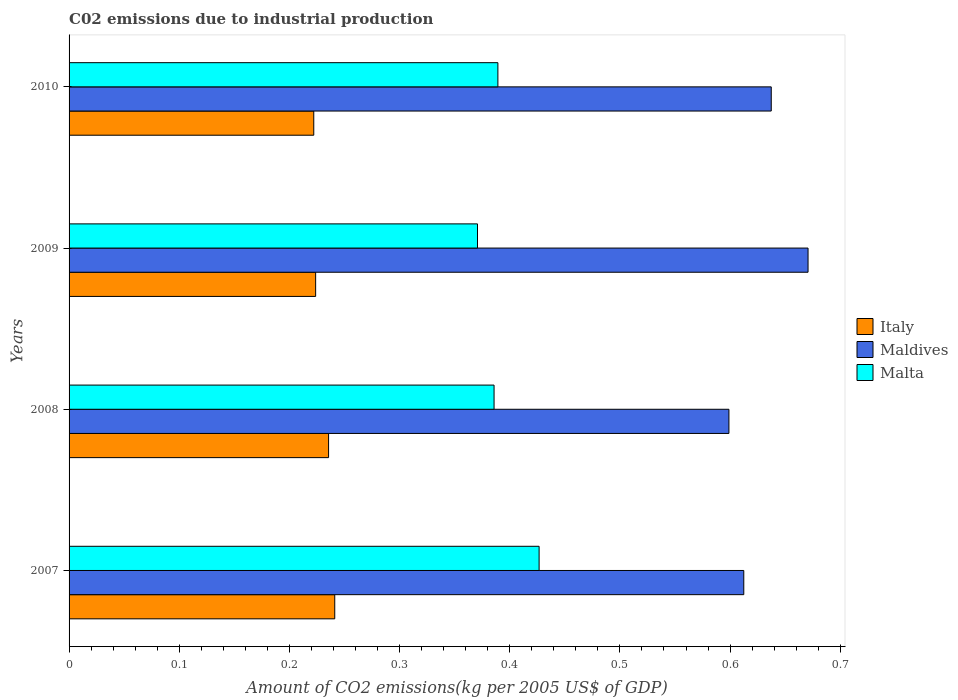How many different coloured bars are there?
Provide a short and direct response. 3. How many bars are there on the 3rd tick from the top?
Ensure brevity in your answer.  3. What is the amount of CO2 emitted due to industrial production in Italy in 2010?
Provide a short and direct response. 0.22. Across all years, what is the maximum amount of CO2 emitted due to industrial production in Maldives?
Offer a terse response. 0.67. Across all years, what is the minimum amount of CO2 emitted due to industrial production in Italy?
Offer a very short reply. 0.22. In which year was the amount of CO2 emitted due to industrial production in Maldives minimum?
Provide a short and direct response. 2008. What is the total amount of CO2 emitted due to industrial production in Malta in the graph?
Provide a succinct answer. 1.57. What is the difference between the amount of CO2 emitted due to industrial production in Maldives in 2008 and that in 2009?
Provide a short and direct response. -0.07. What is the difference between the amount of CO2 emitted due to industrial production in Maldives in 2010 and the amount of CO2 emitted due to industrial production in Italy in 2007?
Your answer should be compact. 0.4. What is the average amount of CO2 emitted due to industrial production in Italy per year?
Offer a terse response. 0.23. In the year 2009, what is the difference between the amount of CO2 emitted due to industrial production in Malta and amount of CO2 emitted due to industrial production in Maldives?
Keep it short and to the point. -0.3. What is the ratio of the amount of CO2 emitted due to industrial production in Malta in 2007 to that in 2009?
Offer a terse response. 1.15. Is the difference between the amount of CO2 emitted due to industrial production in Malta in 2007 and 2010 greater than the difference between the amount of CO2 emitted due to industrial production in Maldives in 2007 and 2010?
Ensure brevity in your answer.  Yes. What is the difference between the highest and the second highest amount of CO2 emitted due to industrial production in Maldives?
Your answer should be very brief. 0.03. What is the difference between the highest and the lowest amount of CO2 emitted due to industrial production in Italy?
Your answer should be very brief. 0.02. In how many years, is the amount of CO2 emitted due to industrial production in Malta greater than the average amount of CO2 emitted due to industrial production in Malta taken over all years?
Your answer should be compact. 1. What does the 3rd bar from the bottom in 2008 represents?
Ensure brevity in your answer.  Malta. How many bars are there?
Provide a succinct answer. 12. Are all the bars in the graph horizontal?
Your answer should be compact. Yes. How many years are there in the graph?
Give a very brief answer. 4. Are the values on the major ticks of X-axis written in scientific E-notation?
Your answer should be very brief. No. Where does the legend appear in the graph?
Ensure brevity in your answer.  Center right. What is the title of the graph?
Keep it short and to the point. C02 emissions due to industrial production. Does "Malta" appear as one of the legend labels in the graph?
Your answer should be very brief. Yes. What is the label or title of the X-axis?
Your answer should be compact. Amount of CO2 emissions(kg per 2005 US$ of GDP). What is the Amount of CO2 emissions(kg per 2005 US$ of GDP) in Italy in 2007?
Keep it short and to the point. 0.24. What is the Amount of CO2 emissions(kg per 2005 US$ of GDP) of Maldives in 2007?
Your answer should be very brief. 0.61. What is the Amount of CO2 emissions(kg per 2005 US$ of GDP) of Malta in 2007?
Make the answer very short. 0.43. What is the Amount of CO2 emissions(kg per 2005 US$ of GDP) in Italy in 2008?
Keep it short and to the point. 0.24. What is the Amount of CO2 emissions(kg per 2005 US$ of GDP) of Maldives in 2008?
Offer a very short reply. 0.6. What is the Amount of CO2 emissions(kg per 2005 US$ of GDP) in Malta in 2008?
Provide a succinct answer. 0.39. What is the Amount of CO2 emissions(kg per 2005 US$ of GDP) of Italy in 2009?
Your response must be concise. 0.22. What is the Amount of CO2 emissions(kg per 2005 US$ of GDP) in Maldives in 2009?
Ensure brevity in your answer.  0.67. What is the Amount of CO2 emissions(kg per 2005 US$ of GDP) of Malta in 2009?
Ensure brevity in your answer.  0.37. What is the Amount of CO2 emissions(kg per 2005 US$ of GDP) in Italy in 2010?
Offer a terse response. 0.22. What is the Amount of CO2 emissions(kg per 2005 US$ of GDP) of Maldives in 2010?
Your response must be concise. 0.64. What is the Amount of CO2 emissions(kg per 2005 US$ of GDP) of Malta in 2010?
Keep it short and to the point. 0.39. Across all years, what is the maximum Amount of CO2 emissions(kg per 2005 US$ of GDP) in Italy?
Your response must be concise. 0.24. Across all years, what is the maximum Amount of CO2 emissions(kg per 2005 US$ of GDP) of Maldives?
Keep it short and to the point. 0.67. Across all years, what is the maximum Amount of CO2 emissions(kg per 2005 US$ of GDP) in Malta?
Offer a terse response. 0.43. Across all years, what is the minimum Amount of CO2 emissions(kg per 2005 US$ of GDP) of Italy?
Make the answer very short. 0.22. Across all years, what is the minimum Amount of CO2 emissions(kg per 2005 US$ of GDP) in Maldives?
Your answer should be very brief. 0.6. Across all years, what is the minimum Amount of CO2 emissions(kg per 2005 US$ of GDP) of Malta?
Give a very brief answer. 0.37. What is the total Amount of CO2 emissions(kg per 2005 US$ of GDP) of Italy in the graph?
Keep it short and to the point. 0.92. What is the total Amount of CO2 emissions(kg per 2005 US$ of GDP) of Maldives in the graph?
Ensure brevity in your answer.  2.52. What is the total Amount of CO2 emissions(kg per 2005 US$ of GDP) of Malta in the graph?
Offer a very short reply. 1.57. What is the difference between the Amount of CO2 emissions(kg per 2005 US$ of GDP) in Italy in 2007 and that in 2008?
Ensure brevity in your answer.  0.01. What is the difference between the Amount of CO2 emissions(kg per 2005 US$ of GDP) of Maldives in 2007 and that in 2008?
Provide a succinct answer. 0.01. What is the difference between the Amount of CO2 emissions(kg per 2005 US$ of GDP) in Malta in 2007 and that in 2008?
Make the answer very short. 0.04. What is the difference between the Amount of CO2 emissions(kg per 2005 US$ of GDP) in Italy in 2007 and that in 2009?
Your response must be concise. 0.02. What is the difference between the Amount of CO2 emissions(kg per 2005 US$ of GDP) in Maldives in 2007 and that in 2009?
Provide a short and direct response. -0.06. What is the difference between the Amount of CO2 emissions(kg per 2005 US$ of GDP) in Malta in 2007 and that in 2009?
Provide a succinct answer. 0.06. What is the difference between the Amount of CO2 emissions(kg per 2005 US$ of GDP) of Italy in 2007 and that in 2010?
Make the answer very short. 0.02. What is the difference between the Amount of CO2 emissions(kg per 2005 US$ of GDP) in Maldives in 2007 and that in 2010?
Your response must be concise. -0.02. What is the difference between the Amount of CO2 emissions(kg per 2005 US$ of GDP) in Malta in 2007 and that in 2010?
Ensure brevity in your answer.  0.04. What is the difference between the Amount of CO2 emissions(kg per 2005 US$ of GDP) of Italy in 2008 and that in 2009?
Ensure brevity in your answer.  0.01. What is the difference between the Amount of CO2 emissions(kg per 2005 US$ of GDP) of Maldives in 2008 and that in 2009?
Give a very brief answer. -0.07. What is the difference between the Amount of CO2 emissions(kg per 2005 US$ of GDP) in Malta in 2008 and that in 2009?
Your answer should be compact. 0.01. What is the difference between the Amount of CO2 emissions(kg per 2005 US$ of GDP) in Italy in 2008 and that in 2010?
Keep it short and to the point. 0.01. What is the difference between the Amount of CO2 emissions(kg per 2005 US$ of GDP) of Maldives in 2008 and that in 2010?
Offer a very short reply. -0.04. What is the difference between the Amount of CO2 emissions(kg per 2005 US$ of GDP) in Malta in 2008 and that in 2010?
Give a very brief answer. -0. What is the difference between the Amount of CO2 emissions(kg per 2005 US$ of GDP) of Italy in 2009 and that in 2010?
Your answer should be very brief. 0. What is the difference between the Amount of CO2 emissions(kg per 2005 US$ of GDP) of Maldives in 2009 and that in 2010?
Your response must be concise. 0.03. What is the difference between the Amount of CO2 emissions(kg per 2005 US$ of GDP) in Malta in 2009 and that in 2010?
Your response must be concise. -0.02. What is the difference between the Amount of CO2 emissions(kg per 2005 US$ of GDP) of Italy in 2007 and the Amount of CO2 emissions(kg per 2005 US$ of GDP) of Maldives in 2008?
Offer a very short reply. -0.36. What is the difference between the Amount of CO2 emissions(kg per 2005 US$ of GDP) in Italy in 2007 and the Amount of CO2 emissions(kg per 2005 US$ of GDP) in Malta in 2008?
Your answer should be very brief. -0.14. What is the difference between the Amount of CO2 emissions(kg per 2005 US$ of GDP) in Maldives in 2007 and the Amount of CO2 emissions(kg per 2005 US$ of GDP) in Malta in 2008?
Your answer should be very brief. 0.23. What is the difference between the Amount of CO2 emissions(kg per 2005 US$ of GDP) of Italy in 2007 and the Amount of CO2 emissions(kg per 2005 US$ of GDP) of Maldives in 2009?
Offer a very short reply. -0.43. What is the difference between the Amount of CO2 emissions(kg per 2005 US$ of GDP) in Italy in 2007 and the Amount of CO2 emissions(kg per 2005 US$ of GDP) in Malta in 2009?
Your answer should be very brief. -0.13. What is the difference between the Amount of CO2 emissions(kg per 2005 US$ of GDP) of Maldives in 2007 and the Amount of CO2 emissions(kg per 2005 US$ of GDP) of Malta in 2009?
Keep it short and to the point. 0.24. What is the difference between the Amount of CO2 emissions(kg per 2005 US$ of GDP) in Italy in 2007 and the Amount of CO2 emissions(kg per 2005 US$ of GDP) in Maldives in 2010?
Offer a very short reply. -0.4. What is the difference between the Amount of CO2 emissions(kg per 2005 US$ of GDP) in Italy in 2007 and the Amount of CO2 emissions(kg per 2005 US$ of GDP) in Malta in 2010?
Your answer should be compact. -0.15. What is the difference between the Amount of CO2 emissions(kg per 2005 US$ of GDP) in Maldives in 2007 and the Amount of CO2 emissions(kg per 2005 US$ of GDP) in Malta in 2010?
Your answer should be compact. 0.22. What is the difference between the Amount of CO2 emissions(kg per 2005 US$ of GDP) in Italy in 2008 and the Amount of CO2 emissions(kg per 2005 US$ of GDP) in Maldives in 2009?
Ensure brevity in your answer.  -0.44. What is the difference between the Amount of CO2 emissions(kg per 2005 US$ of GDP) of Italy in 2008 and the Amount of CO2 emissions(kg per 2005 US$ of GDP) of Malta in 2009?
Make the answer very short. -0.14. What is the difference between the Amount of CO2 emissions(kg per 2005 US$ of GDP) of Maldives in 2008 and the Amount of CO2 emissions(kg per 2005 US$ of GDP) of Malta in 2009?
Provide a short and direct response. 0.23. What is the difference between the Amount of CO2 emissions(kg per 2005 US$ of GDP) in Italy in 2008 and the Amount of CO2 emissions(kg per 2005 US$ of GDP) in Maldives in 2010?
Offer a very short reply. -0.4. What is the difference between the Amount of CO2 emissions(kg per 2005 US$ of GDP) of Italy in 2008 and the Amount of CO2 emissions(kg per 2005 US$ of GDP) of Malta in 2010?
Keep it short and to the point. -0.15. What is the difference between the Amount of CO2 emissions(kg per 2005 US$ of GDP) in Maldives in 2008 and the Amount of CO2 emissions(kg per 2005 US$ of GDP) in Malta in 2010?
Ensure brevity in your answer.  0.21. What is the difference between the Amount of CO2 emissions(kg per 2005 US$ of GDP) of Italy in 2009 and the Amount of CO2 emissions(kg per 2005 US$ of GDP) of Maldives in 2010?
Offer a terse response. -0.41. What is the difference between the Amount of CO2 emissions(kg per 2005 US$ of GDP) of Italy in 2009 and the Amount of CO2 emissions(kg per 2005 US$ of GDP) of Malta in 2010?
Keep it short and to the point. -0.17. What is the difference between the Amount of CO2 emissions(kg per 2005 US$ of GDP) in Maldives in 2009 and the Amount of CO2 emissions(kg per 2005 US$ of GDP) in Malta in 2010?
Your response must be concise. 0.28. What is the average Amount of CO2 emissions(kg per 2005 US$ of GDP) of Italy per year?
Your answer should be very brief. 0.23. What is the average Amount of CO2 emissions(kg per 2005 US$ of GDP) of Maldives per year?
Your response must be concise. 0.63. What is the average Amount of CO2 emissions(kg per 2005 US$ of GDP) in Malta per year?
Provide a short and direct response. 0.39. In the year 2007, what is the difference between the Amount of CO2 emissions(kg per 2005 US$ of GDP) of Italy and Amount of CO2 emissions(kg per 2005 US$ of GDP) of Maldives?
Give a very brief answer. -0.37. In the year 2007, what is the difference between the Amount of CO2 emissions(kg per 2005 US$ of GDP) in Italy and Amount of CO2 emissions(kg per 2005 US$ of GDP) in Malta?
Keep it short and to the point. -0.19. In the year 2007, what is the difference between the Amount of CO2 emissions(kg per 2005 US$ of GDP) of Maldives and Amount of CO2 emissions(kg per 2005 US$ of GDP) of Malta?
Offer a very short reply. 0.19. In the year 2008, what is the difference between the Amount of CO2 emissions(kg per 2005 US$ of GDP) of Italy and Amount of CO2 emissions(kg per 2005 US$ of GDP) of Maldives?
Provide a succinct answer. -0.36. In the year 2008, what is the difference between the Amount of CO2 emissions(kg per 2005 US$ of GDP) of Italy and Amount of CO2 emissions(kg per 2005 US$ of GDP) of Malta?
Give a very brief answer. -0.15. In the year 2008, what is the difference between the Amount of CO2 emissions(kg per 2005 US$ of GDP) of Maldives and Amount of CO2 emissions(kg per 2005 US$ of GDP) of Malta?
Offer a very short reply. 0.21. In the year 2009, what is the difference between the Amount of CO2 emissions(kg per 2005 US$ of GDP) in Italy and Amount of CO2 emissions(kg per 2005 US$ of GDP) in Maldives?
Your answer should be compact. -0.45. In the year 2009, what is the difference between the Amount of CO2 emissions(kg per 2005 US$ of GDP) of Italy and Amount of CO2 emissions(kg per 2005 US$ of GDP) of Malta?
Ensure brevity in your answer.  -0.15. In the year 2010, what is the difference between the Amount of CO2 emissions(kg per 2005 US$ of GDP) of Italy and Amount of CO2 emissions(kg per 2005 US$ of GDP) of Maldives?
Provide a short and direct response. -0.42. In the year 2010, what is the difference between the Amount of CO2 emissions(kg per 2005 US$ of GDP) of Italy and Amount of CO2 emissions(kg per 2005 US$ of GDP) of Malta?
Your answer should be compact. -0.17. In the year 2010, what is the difference between the Amount of CO2 emissions(kg per 2005 US$ of GDP) in Maldives and Amount of CO2 emissions(kg per 2005 US$ of GDP) in Malta?
Provide a succinct answer. 0.25. What is the ratio of the Amount of CO2 emissions(kg per 2005 US$ of GDP) of Italy in 2007 to that in 2008?
Provide a succinct answer. 1.02. What is the ratio of the Amount of CO2 emissions(kg per 2005 US$ of GDP) in Maldives in 2007 to that in 2008?
Your answer should be very brief. 1.02. What is the ratio of the Amount of CO2 emissions(kg per 2005 US$ of GDP) in Malta in 2007 to that in 2008?
Offer a terse response. 1.11. What is the ratio of the Amount of CO2 emissions(kg per 2005 US$ of GDP) of Italy in 2007 to that in 2009?
Offer a very short reply. 1.08. What is the ratio of the Amount of CO2 emissions(kg per 2005 US$ of GDP) of Maldives in 2007 to that in 2009?
Your answer should be compact. 0.91. What is the ratio of the Amount of CO2 emissions(kg per 2005 US$ of GDP) of Malta in 2007 to that in 2009?
Your response must be concise. 1.15. What is the ratio of the Amount of CO2 emissions(kg per 2005 US$ of GDP) in Italy in 2007 to that in 2010?
Offer a terse response. 1.09. What is the ratio of the Amount of CO2 emissions(kg per 2005 US$ of GDP) of Maldives in 2007 to that in 2010?
Offer a terse response. 0.96. What is the ratio of the Amount of CO2 emissions(kg per 2005 US$ of GDP) in Malta in 2007 to that in 2010?
Provide a short and direct response. 1.1. What is the ratio of the Amount of CO2 emissions(kg per 2005 US$ of GDP) of Italy in 2008 to that in 2009?
Offer a very short reply. 1.05. What is the ratio of the Amount of CO2 emissions(kg per 2005 US$ of GDP) in Maldives in 2008 to that in 2009?
Keep it short and to the point. 0.89. What is the ratio of the Amount of CO2 emissions(kg per 2005 US$ of GDP) of Malta in 2008 to that in 2009?
Provide a short and direct response. 1.04. What is the ratio of the Amount of CO2 emissions(kg per 2005 US$ of GDP) of Italy in 2008 to that in 2010?
Offer a terse response. 1.06. What is the ratio of the Amount of CO2 emissions(kg per 2005 US$ of GDP) of Maldives in 2008 to that in 2010?
Offer a terse response. 0.94. What is the ratio of the Amount of CO2 emissions(kg per 2005 US$ of GDP) in Italy in 2009 to that in 2010?
Your answer should be compact. 1.01. What is the ratio of the Amount of CO2 emissions(kg per 2005 US$ of GDP) in Maldives in 2009 to that in 2010?
Give a very brief answer. 1.05. What is the ratio of the Amount of CO2 emissions(kg per 2005 US$ of GDP) of Malta in 2009 to that in 2010?
Provide a succinct answer. 0.95. What is the difference between the highest and the second highest Amount of CO2 emissions(kg per 2005 US$ of GDP) of Italy?
Your answer should be very brief. 0.01. What is the difference between the highest and the second highest Amount of CO2 emissions(kg per 2005 US$ of GDP) of Maldives?
Offer a very short reply. 0.03. What is the difference between the highest and the second highest Amount of CO2 emissions(kg per 2005 US$ of GDP) in Malta?
Offer a terse response. 0.04. What is the difference between the highest and the lowest Amount of CO2 emissions(kg per 2005 US$ of GDP) of Italy?
Ensure brevity in your answer.  0.02. What is the difference between the highest and the lowest Amount of CO2 emissions(kg per 2005 US$ of GDP) in Maldives?
Provide a succinct answer. 0.07. What is the difference between the highest and the lowest Amount of CO2 emissions(kg per 2005 US$ of GDP) of Malta?
Keep it short and to the point. 0.06. 